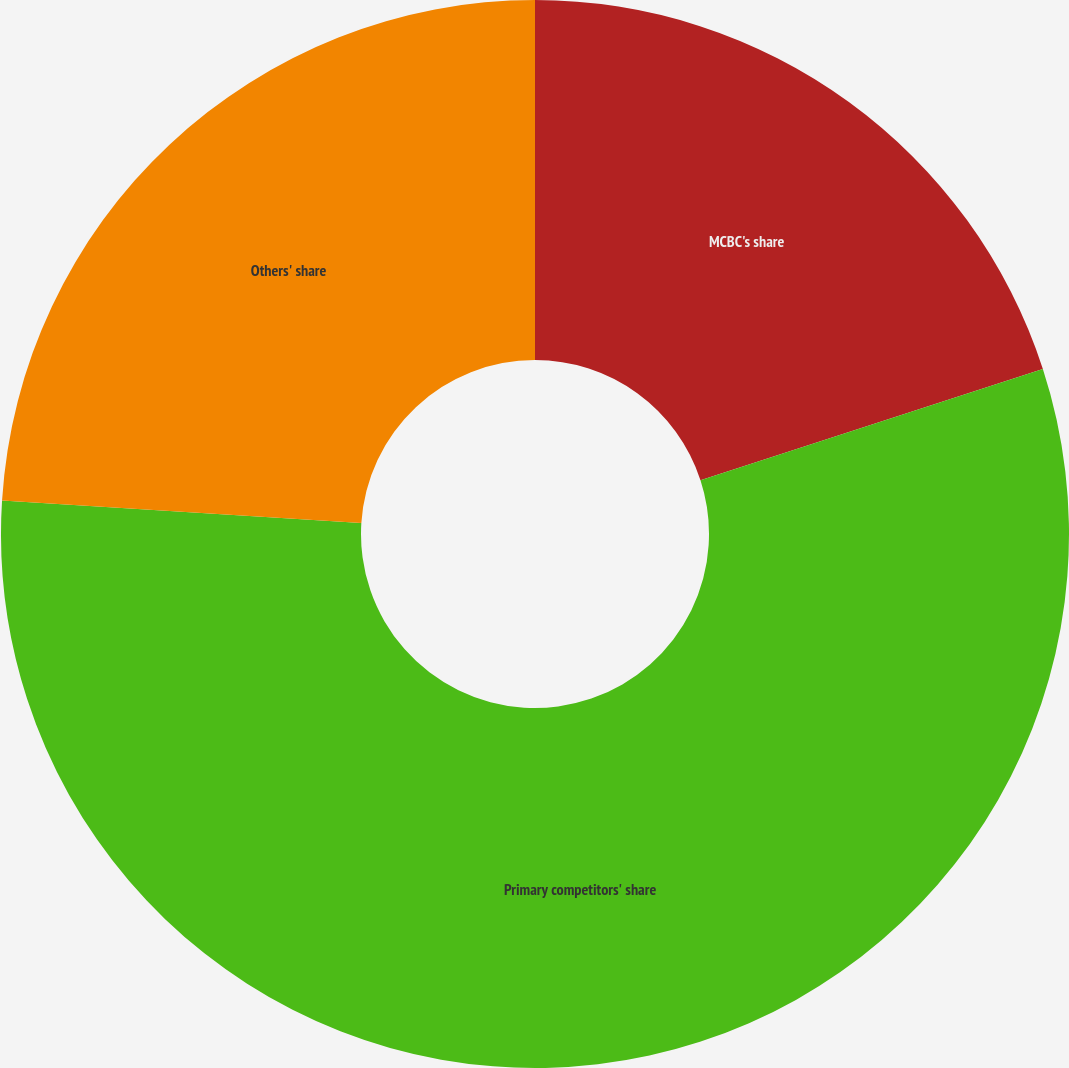<chart> <loc_0><loc_0><loc_500><loc_500><pie_chart><fcel>MCBC's share<fcel>Primary competitors' share<fcel>Others' share<nl><fcel>20.0%<fcel>56.0%<fcel>24.0%<nl></chart> 